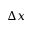Convert formula to latex. <formula><loc_0><loc_0><loc_500><loc_500>\Delta x</formula> 